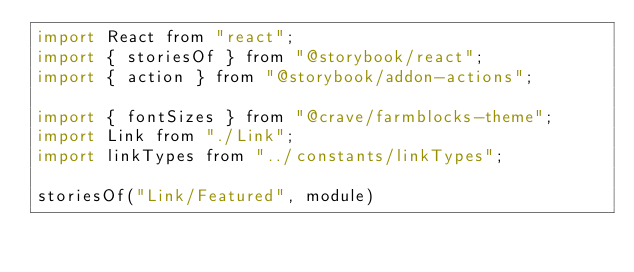<code> <loc_0><loc_0><loc_500><loc_500><_JavaScript_>import React from "react";
import { storiesOf } from "@storybook/react";
import { action } from "@storybook/addon-actions";

import { fontSizes } from "@crave/farmblocks-theme";
import Link from "./Link";
import linkTypes from "../constants/linkTypes";

storiesOf("Link/Featured", module)</code> 